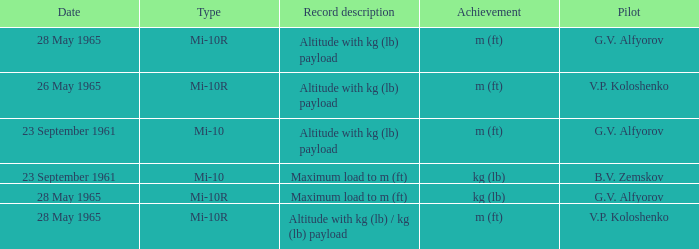Record description of altitude with kg (lb) payload, and a Pilot of g.v. alfyorov had what type? Mi-10, Mi-10R. Help me parse the entirety of this table. {'header': ['Date', 'Type', 'Record description', 'Achievement', 'Pilot'], 'rows': [['28 May 1965', 'Mi-10R', 'Altitude with kg (lb) payload', 'm (ft)', 'G.V. Alfyorov'], ['26 May 1965', 'Mi-10R', 'Altitude with kg (lb) payload', 'm (ft)', 'V.P. Koloshenko'], ['23 September 1961', 'Mi-10', 'Altitude with kg (lb) payload', 'm (ft)', 'G.V. Alfyorov'], ['23 September 1961', 'Mi-10', 'Maximum load to m (ft)', 'kg (lb)', 'B.V. Zemskov'], ['28 May 1965', 'Mi-10R', 'Maximum load to m (ft)', 'kg (lb)', 'G.V. Alfyorov'], ['28 May 1965', 'Mi-10R', 'Altitude with kg (lb) / kg (lb) payload', 'm (ft)', 'V.P. Koloshenko']]} 